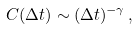Convert formula to latex. <formula><loc_0><loc_0><loc_500><loc_500>C ( \Delta t ) \sim ( \Delta t ) ^ { - \gamma } \, ,</formula> 